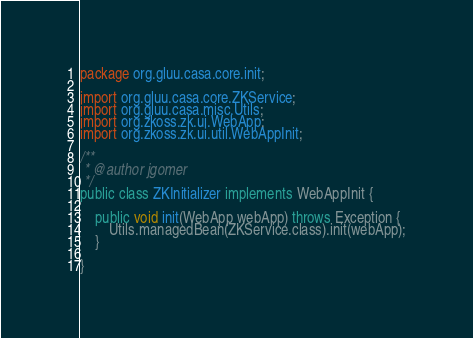Convert code to text. <code><loc_0><loc_0><loc_500><loc_500><_Java_>package org.gluu.casa.core.init;

import org.gluu.casa.core.ZKService;
import org.gluu.casa.misc.Utils;
import org.zkoss.zk.ui.WebApp;
import org.zkoss.zk.ui.util.WebAppInit;

/**
 * @author jgomer
 */
public class ZKInitializer implements WebAppInit {

    public void init(WebApp webApp) throws Exception {
        Utils.managedBean(ZKService.class).init(webApp);
    }

}
</code> 